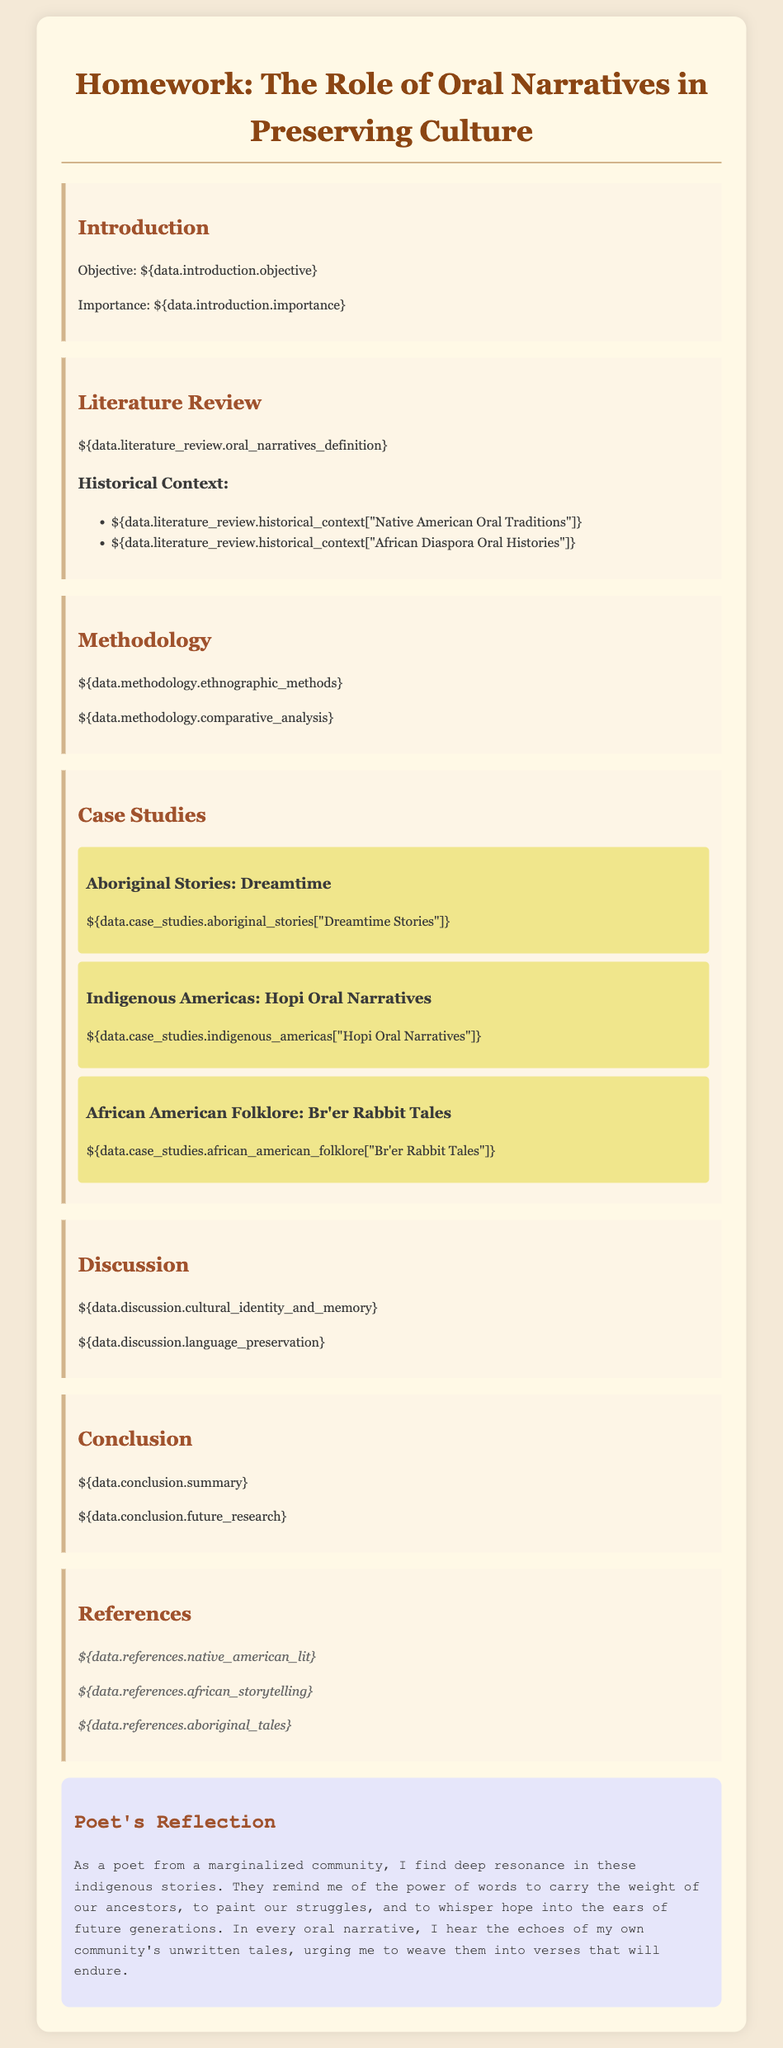What is the objective of the research paper? The objective is stated in the introduction section, which focuses on the significance of oral narratives in marginalized communities.
Answer: Preservation of culture What historical context is provided for Native American Oral Traditions? The document lists specific historical contexts under the literature review section related to oral narratives.
Answer: Rich oral traditions What ethnographic methods are mentioned in the methodology? The methodology section elaborates on various research techniques, including ethnographic methods, that are utilized for the study.
Answer: Ethnographic methods How many case studies are presented in the document? The case studies section includes a specific number of examples of oral narratives from different cultures.
Answer: Three What is a prominent theme discussed in the Discussion section? The discussion part illuminates critical ideas around cultural identity and memory, which are two key themes highlighted.
Answer: Cultural identity What reference is cited regarding African storytelling? The references section includes specific citations related to the literature used in discussing oral narratives.
Answer: African storytelling What do the Aboriginal Stories primarily represent? The case study section outlines the contents of the Aboriginal Stories and their cultural significance.
Answer: Dreamtime narratives What is the main focus of the Poet's Reflection? The Poet's Reflection emphasizes the importance of storytelling and its connection to the poet's experiences and community.
Answer: Power of words 